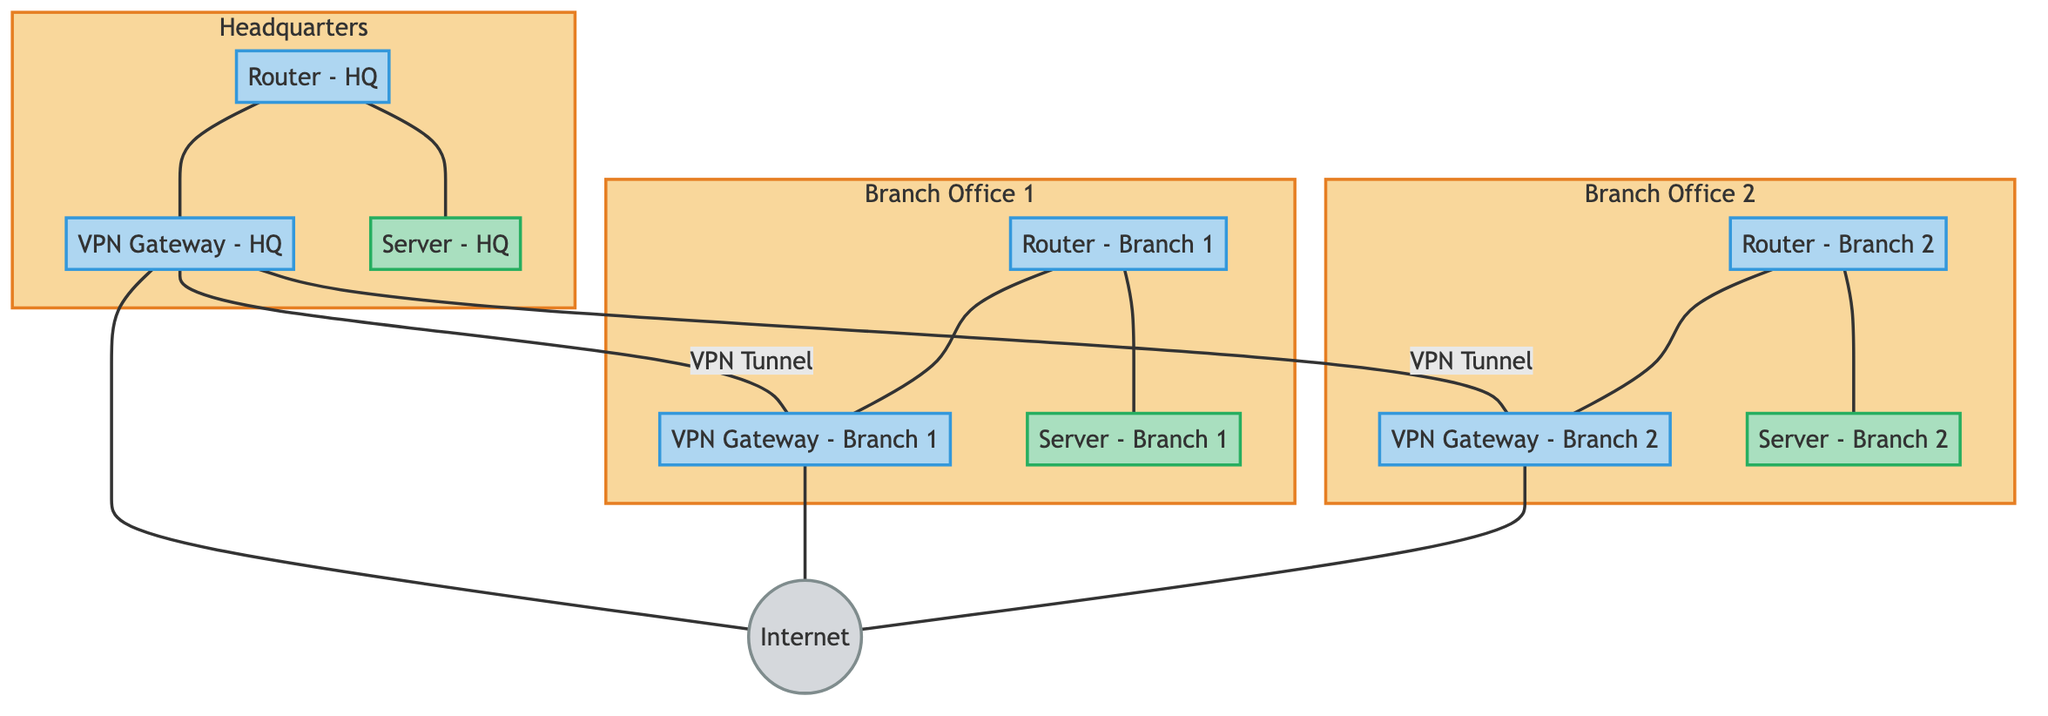What are the three main sites in this network diagram? The diagram lists three main sites: Headquarters, Branch Office 1, and Branch Office 2.
Answer: Headquarters, Branch Office 1, Branch Office 2 How many VPN gateways are shown in the diagram? The diagram indicates three VPN gateways: one for each site (HQ, Branch 1, Branch 2).
Answer: 3 What type of connection exists between the VPN Gateway - HQ and VPN Gateway - Branch 1? The connection between these two nodes is labeled as a VPN Tunnel.
Answer: VPN Tunnel How many servers are depicted within the diagram? There are three servers, one located at each site (HQ, Branch 1, Branch 2).
Answer: 3 What is the relationship between the Router - HQ and the Server - HQ? The relationship is a direct connection, specifically described as "HQ Router to Server."
Answer: Connection Which site is directly connected to the Internet via a VPN Gateway? All three sites (Headquarters, Branch Office 1, and Branch Office 2) have direct connections to the Internet through their respective VPN Gateways.
Answer: All sites What type of network device connects the Branch Office 2 to the VPN Gateway - Branch 2? The connection is made by the Router - Branch 2.
Answer: Router - Branch 2 Why does the Headquarters have two VPN tunnels, and what are the other sites connected to? The Headquarters connects to both Branch Office 1 and Branch Office 2 via separate VPN tunnels for secure communication between these sites.
Answer: Branch Office 1, Branch Office 2 What is the primary purpose of the VPN gateways in this network? The primary purpose of the VPN gateways is to establish secure VPN tunnels between the sites.
Answer: Establish secure VPN tunnels 